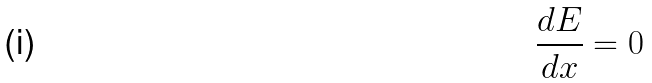<formula> <loc_0><loc_0><loc_500><loc_500>\frac { d E } { d x } = 0</formula> 